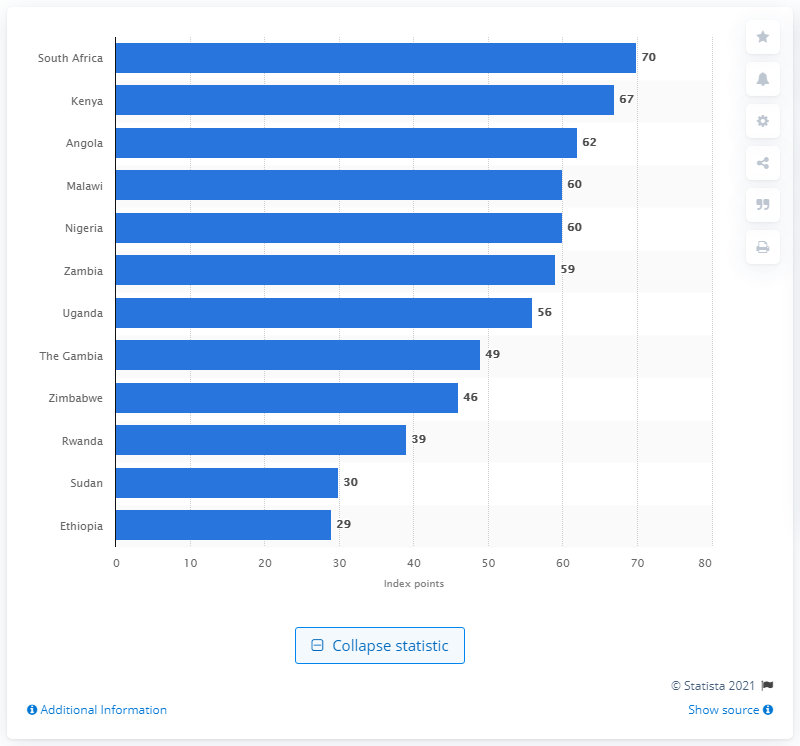Point out several critical features in this image. In 2019, Ethiopia had a Human Development Index (HDI) score of 0.595, which placed it at position 153 out of 189 countries. Specifically, Ethiopia had a score of 0.595 out of 100, which translates to 29 index points. According to the Global Innovation Index 2022, South Africa was ranked first with 70 index points, indicating its strong performance in innovation-related activities. 